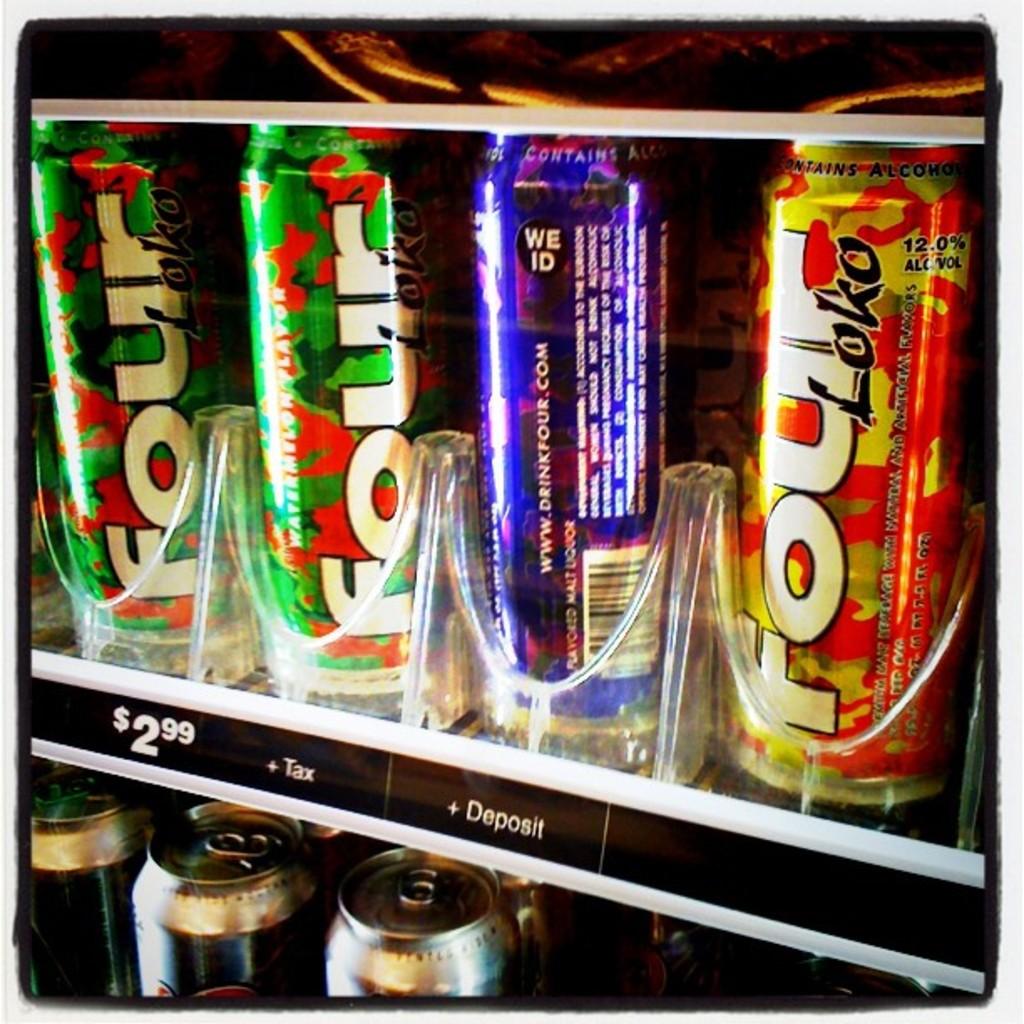What is the price of the first drink?
Ensure brevity in your answer.  2.99. What is the name of the beverages in the cooler?
Provide a short and direct response. Four loko. 